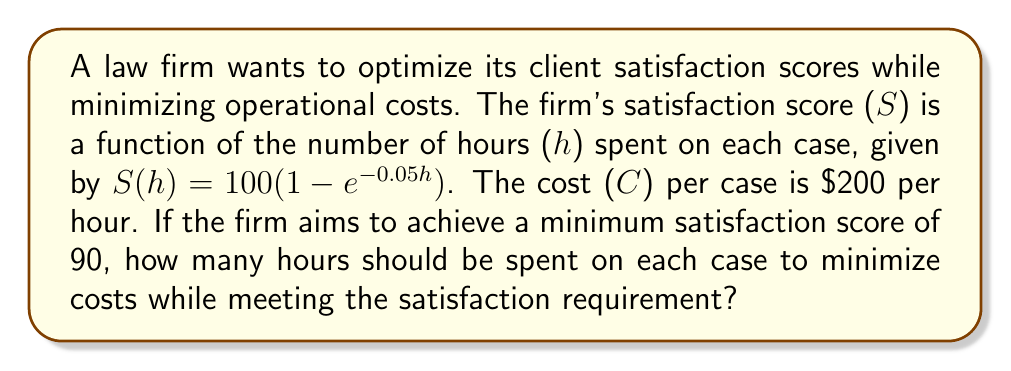Show me your answer to this math problem. To solve this optimization problem, we need to follow these steps:

1) First, we need to determine the number of hours required to achieve a satisfaction score of 90:

   $90 = 100(1 - e^{-0.05h})$
   $0.9 = 1 - e^{-0.05h}$
   $0.1 = e^{-0.05h}$
   $\ln(0.1) = -0.05h$
   $h = \frac{-\ln(0.1)}{0.05} \approx 46.05$ hours

2) This means that the firm needs to spend at least 46.05 hours per case to meet the satisfaction requirement.

3) Since the cost is directly proportional to the number of hours spent ($C = 200h$), and we want to minimize costs, the optimal solution is to spend exactly 46.05 hours per case.

4) The minimum cost per case would be:

   $C = 200 * 46.05 = 9,210$

Therefore, to minimize costs while achieving a satisfaction score of 90, the firm should spend 46.05 hours on each case, resulting in a cost of $9,210 per case.
Answer: The firm should spend 46.05 hours on each case, costing $9,210 per case. 